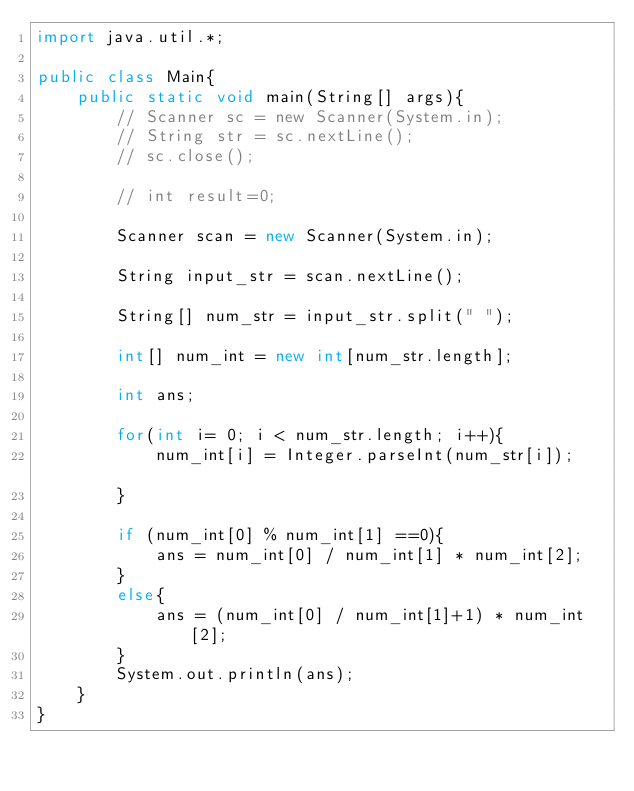<code> <loc_0><loc_0><loc_500><loc_500><_Java_>import java.util.*;

public class Main{
	public static void main(String[] args){
		// Scanner sc = new Scanner(System.in);
		// String str = sc.nextLine();
		// sc.close();

		// int result=0;

		Scanner scan = new Scanner(System.in);

		String input_str = scan.nextLine();

		String[] num_str = input_str.split(" ");

		int[] num_int = new int[num_str.length];

		int ans;

		for(int i= 0; i < num_str.length; i++){
			num_int[i] = Integer.parseInt(num_str[i]);		
		}

		if (num_int[0] % num_int[1] ==0){
			ans = num_int[0] / num_int[1] * num_int[2];
		}
		else{
			ans = (num_int[0] / num_int[1]+1) * num_int[2];
		}
		System.out.println(ans);
	}
}</code> 